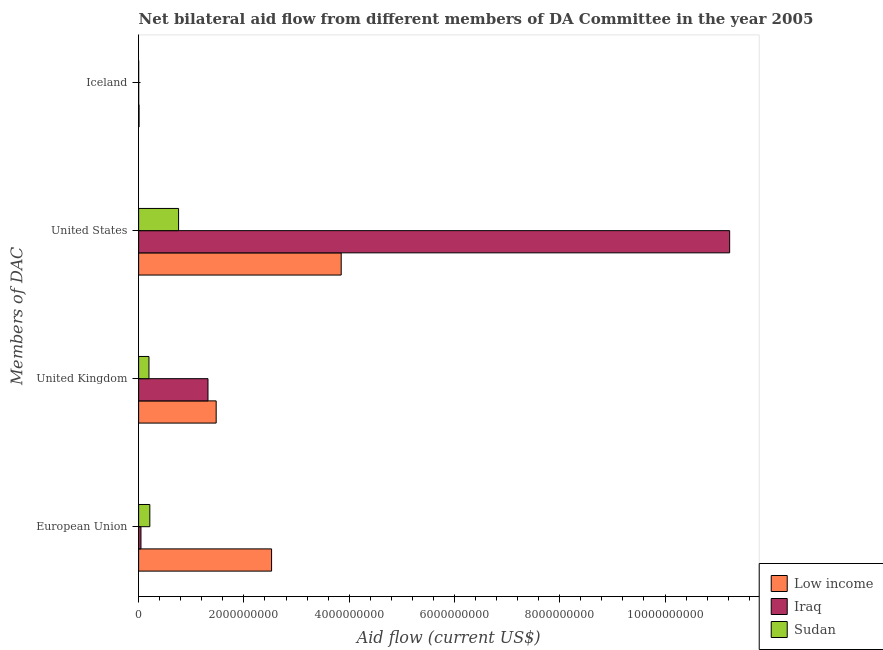How many different coloured bars are there?
Your answer should be compact. 3. What is the label of the 4th group of bars from the top?
Your response must be concise. European Union. What is the amount of aid given by us in Sudan?
Your answer should be very brief. 7.59e+08. Across all countries, what is the maximum amount of aid given by iceland?
Provide a succinct answer. 8.29e+06. Across all countries, what is the minimum amount of aid given by iceland?
Make the answer very short. 1.60e+05. In which country was the amount of aid given by iceland minimum?
Make the answer very short. Sudan. What is the total amount of aid given by us in the graph?
Offer a very short reply. 1.58e+1. What is the difference between the amount of aid given by eu in Sudan and that in Low income?
Your response must be concise. -2.31e+09. What is the difference between the amount of aid given by iceland in Sudan and the amount of aid given by uk in Low income?
Make the answer very short. -1.47e+09. What is the average amount of aid given by eu per country?
Your answer should be compact. 9.28e+08. What is the difference between the amount of aid given by uk and amount of aid given by eu in Sudan?
Keep it short and to the point. -1.63e+07. What is the ratio of the amount of aid given by eu in Sudan to that in Iraq?
Offer a very short reply. 4.79. Is the amount of aid given by eu in Sudan less than that in Low income?
Your response must be concise. Yes. Is the difference between the amount of aid given by uk in Iraq and Low income greater than the difference between the amount of aid given by iceland in Iraq and Low income?
Offer a terse response. No. What is the difference between the highest and the second highest amount of aid given by eu?
Your answer should be very brief. 2.31e+09. What is the difference between the highest and the lowest amount of aid given by uk?
Your answer should be compact. 1.28e+09. In how many countries, is the amount of aid given by uk greater than the average amount of aid given by uk taken over all countries?
Give a very brief answer. 2. What does the 1st bar from the top in European Union represents?
Your answer should be very brief. Sudan. What does the 2nd bar from the bottom in United States represents?
Your answer should be compact. Iraq. Are all the bars in the graph horizontal?
Your answer should be compact. Yes. What is the difference between two consecutive major ticks on the X-axis?
Offer a terse response. 2.00e+09. Where does the legend appear in the graph?
Your answer should be compact. Bottom right. What is the title of the graph?
Your answer should be compact. Net bilateral aid flow from different members of DA Committee in the year 2005. What is the label or title of the X-axis?
Provide a short and direct response. Aid flow (current US$). What is the label or title of the Y-axis?
Offer a very short reply. Members of DAC. What is the Aid flow (current US$) of Low income in European Union?
Provide a short and direct response. 2.53e+09. What is the Aid flow (current US$) in Iraq in European Union?
Make the answer very short. 4.45e+07. What is the Aid flow (current US$) of Sudan in European Union?
Provide a succinct answer. 2.13e+08. What is the Aid flow (current US$) of Low income in United Kingdom?
Give a very brief answer. 1.47e+09. What is the Aid flow (current US$) in Iraq in United Kingdom?
Keep it short and to the point. 1.32e+09. What is the Aid flow (current US$) in Sudan in United Kingdom?
Offer a terse response. 1.96e+08. What is the Aid flow (current US$) in Low income in United States?
Provide a short and direct response. 3.85e+09. What is the Aid flow (current US$) of Iraq in United States?
Provide a short and direct response. 1.12e+1. What is the Aid flow (current US$) of Sudan in United States?
Provide a short and direct response. 7.59e+08. What is the Aid flow (current US$) in Low income in Iceland?
Your answer should be very brief. 8.29e+06. What is the Aid flow (current US$) of Iraq in Iceland?
Your answer should be very brief. 1.10e+06. Across all Members of DAC, what is the maximum Aid flow (current US$) in Low income?
Keep it short and to the point. 3.85e+09. Across all Members of DAC, what is the maximum Aid flow (current US$) of Iraq?
Provide a short and direct response. 1.12e+1. Across all Members of DAC, what is the maximum Aid flow (current US$) in Sudan?
Keep it short and to the point. 7.59e+08. Across all Members of DAC, what is the minimum Aid flow (current US$) of Low income?
Give a very brief answer. 8.29e+06. Across all Members of DAC, what is the minimum Aid flow (current US$) of Iraq?
Your answer should be very brief. 1.10e+06. What is the total Aid flow (current US$) in Low income in the graph?
Keep it short and to the point. 7.86e+09. What is the total Aid flow (current US$) in Iraq in the graph?
Offer a terse response. 1.26e+1. What is the total Aid flow (current US$) of Sudan in the graph?
Offer a very short reply. 1.17e+09. What is the difference between the Aid flow (current US$) in Low income in European Union and that in United Kingdom?
Ensure brevity in your answer.  1.05e+09. What is the difference between the Aid flow (current US$) of Iraq in European Union and that in United Kingdom?
Your answer should be compact. -1.27e+09. What is the difference between the Aid flow (current US$) of Sudan in European Union and that in United Kingdom?
Provide a succinct answer. 1.63e+07. What is the difference between the Aid flow (current US$) in Low income in European Union and that in United States?
Ensure brevity in your answer.  -1.32e+09. What is the difference between the Aid flow (current US$) of Iraq in European Union and that in United States?
Ensure brevity in your answer.  -1.12e+1. What is the difference between the Aid flow (current US$) of Sudan in European Union and that in United States?
Provide a short and direct response. -5.46e+08. What is the difference between the Aid flow (current US$) of Low income in European Union and that in Iceland?
Provide a short and direct response. 2.52e+09. What is the difference between the Aid flow (current US$) in Iraq in European Union and that in Iceland?
Your answer should be very brief. 4.34e+07. What is the difference between the Aid flow (current US$) of Sudan in European Union and that in Iceland?
Ensure brevity in your answer.  2.13e+08. What is the difference between the Aid flow (current US$) in Low income in United Kingdom and that in United States?
Your answer should be very brief. -2.38e+09. What is the difference between the Aid flow (current US$) in Iraq in United Kingdom and that in United States?
Your answer should be very brief. -9.91e+09. What is the difference between the Aid flow (current US$) in Sudan in United Kingdom and that in United States?
Give a very brief answer. -5.63e+08. What is the difference between the Aid flow (current US$) in Low income in United Kingdom and that in Iceland?
Keep it short and to the point. 1.46e+09. What is the difference between the Aid flow (current US$) of Iraq in United Kingdom and that in Iceland?
Give a very brief answer. 1.32e+09. What is the difference between the Aid flow (current US$) in Sudan in United Kingdom and that in Iceland?
Ensure brevity in your answer.  1.96e+08. What is the difference between the Aid flow (current US$) of Low income in United States and that in Iceland?
Make the answer very short. 3.84e+09. What is the difference between the Aid flow (current US$) in Iraq in United States and that in Iceland?
Keep it short and to the point. 1.12e+1. What is the difference between the Aid flow (current US$) of Sudan in United States and that in Iceland?
Provide a succinct answer. 7.59e+08. What is the difference between the Aid flow (current US$) of Low income in European Union and the Aid flow (current US$) of Iraq in United Kingdom?
Keep it short and to the point. 1.21e+09. What is the difference between the Aid flow (current US$) of Low income in European Union and the Aid flow (current US$) of Sudan in United Kingdom?
Offer a terse response. 2.33e+09. What is the difference between the Aid flow (current US$) in Iraq in European Union and the Aid flow (current US$) in Sudan in United Kingdom?
Offer a terse response. -1.52e+08. What is the difference between the Aid flow (current US$) of Low income in European Union and the Aid flow (current US$) of Iraq in United States?
Provide a succinct answer. -8.70e+09. What is the difference between the Aid flow (current US$) in Low income in European Union and the Aid flow (current US$) in Sudan in United States?
Provide a short and direct response. 1.77e+09. What is the difference between the Aid flow (current US$) of Iraq in European Union and the Aid flow (current US$) of Sudan in United States?
Provide a short and direct response. -7.15e+08. What is the difference between the Aid flow (current US$) of Low income in European Union and the Aid flow (current US$) of Iraq in Iceland?
Keep it short and to the point. 2.52e+09. What is the difference between the Aid flow (current US$) of Low income in European Union and the Aid flow (current US$) of Sudan in Iceland?
Offer a terse response. 2.53e+09. What is the difference between the Aid flow (current US$) of Iraq in European Union and the Aid flow (current US$) of Sudan in Iceland?
Offer a terse response. 4.43e+07. What is the difference between the Aid flow (current US$) in Low income in United Kingdom and the Aid flow (current US$) in Iraq in United States?
Keep it short and to the point. -9.75e+09. What is the difference between the Aid flow (current US$) in Low income in United Kingdom and the Aid flow (current US$) in Sudan in United States?
Your answer should be very brief. 7.14e+08. What is the difference between the Aid flow (current US$) in Iraq in United Kingdom and the Aid flow (current US$) in Sudan in United States?
Give a very brief answer. 5.58e+08. What is the difference between the Aid flow (current US$) in Low income in United Kingdom and the Aid flow (current US$) in Iraq in Iceland?
Provide a succinct answer. 1.47e+09. What is the difference between the Aid flow (current US$) of Low income in United Kingdom and the Aid flow (current US$) of Sudan in Iceland?
Ensure brevity in your answer.  1.47e+09. What is the difference between the Aid flow (current US$) in Iraq in United Kingdom and the Aid flow (current US$) in Sudan in Iceland?
Your answer should be very brief. 1.32e+09. What is the difference between the Aid flow (current US$) of Low income in United States and the Aid flow (current US$) of Iraq in Iceland?
Offer a very short reply. 3.85e+09. What is the difference between the Aid flow (current US$) in Low income in United States and the Aid flow (current US$) in Sudan in Iceland?
Provide a short and direct response. 3.85e+09. What is the difference between the Aid flow (current US$) in Iraq in United States and the Aid flow (current US$) in Sudan in Iceland?
Your answer should be very brief. 1.12e+1. What is the average Aid flow (current US$) in Low income per Members of DAC?
Offer a terse response. 1.96e+09. What is the average Aid flow (current US$) in Iraq per Members of DAC?
Your response must be concise. 3.15e+09. What is the average Aid flow (current US$) of Sudan per Members of DAC?
Provide a succinct answer. 2.92e+08. What is the difference between the Aid flow (current US$) of Low income and Aid flow (current US$) of Iraq in European Union?
Offer a very short reply. 2.48e+09. What is the difference between the Aid flow (current US$) of Low income and Aid flow (current US$) of Sudan in European Union?
Keep it short and to the point. 2.31e+09. What is the difference between the Aid flow (current US$) in Iraq and Aid flow (current US$) in Sudan in European Union?
Give a very brief answer. -1.68e+08. What is the difference between the Aid flow (current US$) in Low income and Aid flow (current US$) in Iraq in United Kingdom?
Give a very brief answer. 1.56e+08. What is the difference between the Aid flow (current US$) of Low income and Aid flow (current US$) of Sudan in United Kingdom?
Your response must be concise. 1.28e+09. What is the difference between the Aid flow (current US$) of Iraq and Aid flow (current US$) of Sudan in United Kingdom?
Ensure brevity in your answer.  1.12e+09. What is the difference between the Aid flow (current US$) of Low income and Aid flow (current US$) of Iraq in United States?
Offer a terse response. -7.38e+09. What is the difference between the Aid flow (current US$) in Low income and Aid flow (current US$) in Sudan in United States?
Your response must be concise. 3.09e+09. What is the difference between the Aid flow (current US$) of Iraq and Aid flow (current US$) of Sudan in United States?
Make the answer very short. 1.05e+1. What is the difference between the Aid flow (current US$) in Low income and Aid flow (current US$) in Iraq in Iceland?
Your answer should be compact. 7.19e+06. What is the difference between the Aid flow (current US$) of Low income and Aid flow (current US$) of Sudan in Iceland?
Offer a terse response. 8.13e+06. What is the difference between the Aid flow (current US$) in Iraq and Aid flow (current US$) in Sudan in Iceland?
Ensure brevity in your answer.  9.40e+05. What is the ratio of the Aid flow (current US$) in Low income in European Union to that in United Kingdom?
Provide a succinct answer. 1.71. What is the ratio of the Aid flow (current US$) of Iraq in European Union to that in United Kingdom?
Make the answer very short. 0.03. What is the ratio of the Aid flow (current US$) of Sudan in European Union to that in United Kingdom?
Give a very brief answer. 1.08. What is the ratio of the Aid flow (current US$) of Low income in European Union to that in United States?
Ensure brevity in your answer.  0.66. What is the ratio of the Aid flow (current US$) in Iraq in European Union to that in United States?
Provide a short and direct response. 0. What is the ratio of the Aid flow (current US$) of Sudan in European Union to that in United States?
Provide a succinct answer. 0.28. What is the ratio of the Aid flow (current US$) of Low income in European Union to that in Iceland?
Keep it short and to the point. 304.65. What is the ratio of the Aid flow (current US$) of Iraq in European Union to that in Iceland?
Your response must be concise. 40.42. What is the ratio of the Aid flow (current US$) of Sudan in European Union to that in Iceland?
Provide a short and direct response. 1330. What is the ratio of the Aid flow (current US$) of Low income in United Kingdom to that in United States?
Keep it short and to the point. 0.38. What is the ratio of the Aid flow (current US$) in Iraq in United Kingdom to that in United States?
Offer a very short reply. 0.12. What is the ratio of the Aid flow (current US$) of Sudan in United Kingdom to that in United States?
Your answer should be compact. 0.26. What is the ratio of the Aid flow (current US$) of Low income in United Kingdom to that in Iceland?
Provide a succinct answer. 177.71. What is the ratio of the Aid flow (current US$) of Iraq in United Kingdom to that in Iceland?
Make the answer very short. 1197.75. What is the ratio of the Aid flow (current US$) of Sudan in United Kingdom to that in Iceland?
Your answer should be very brief. 1227.88. What is the ratio of the Aid flow (current US$) of Low income in United States to that in Iceland?
Provide a short and direct response. 464.21. What is the ratio of the Aid flow (current US$) in Iraq in United States to that in Iceland?
Give a very brief answer. 1.02e+04. What is the ratio of the Aid flow (current US$) in Sudan in United States to that in Iceland?
Ensure brevity in your answer.  4744. What is the difference between the highest and the second highest Aid flow (current US$) of Low income?
Keep it short and to the point. 1.32e+09. What is the difference between the highest and the second highest Aid flow (current US$) of Iraq?
Your answer should be very brief. 9.91e+09. What is the difference between the highest and the second highest Aid flow (current US$) in Sudan?
Your answer should be very brief. 5.46e+08. What is the difference between the highest and the lowest Aid flow (current US$) in Low income?
Ensure brevity in your answer.  3.84e+09. What is the difference between the highest and the lowest Aid flow (current US$) in Iraq?
Keep it short and to the point. 1.12e+1. What is the difference between the highest and the lowest Aid flow (current US$) of Sudan?
Keep it short and to the point. 7.59e+08. 